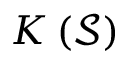Convert formula to latex. <formula><loc_0><loc_0><loc_500><loc_500>K \left ( \mathcal { S } \right )</formula> 